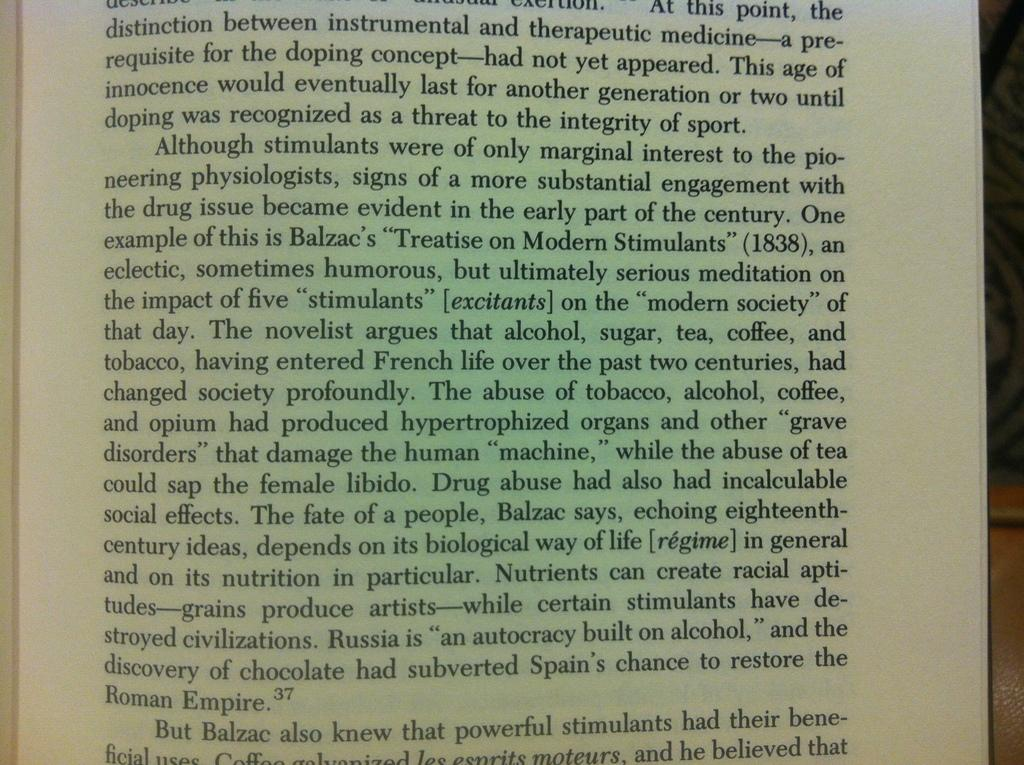<image>
Offer a succinct explanation of the picture presented. A page of text discussing various stimulants used throughout history. 